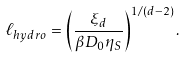Convert formula to latex. <formula><loc_0><loc_0><loc_500><loc_500>\ell _ { h y d r o } = \left ( \frac { \xi _ { d } } { \beta D _ { 0 } \eta _ { S } } \right ) ^ { 1 / ( d - 2 ) } .</formula> 